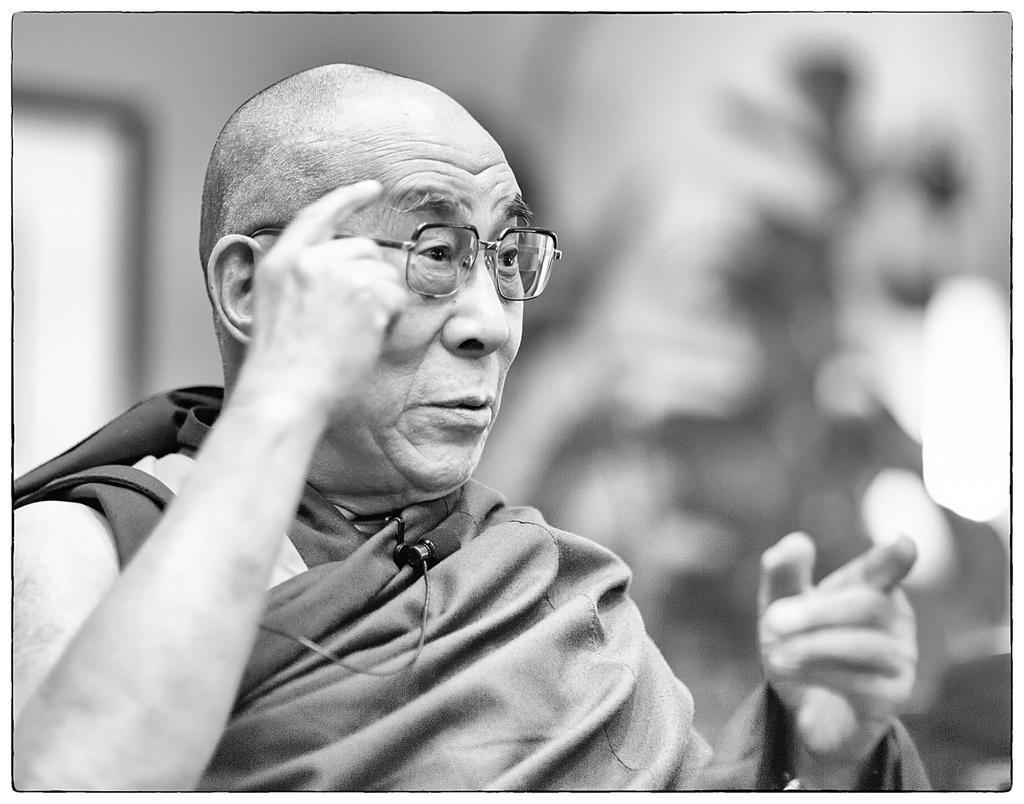Describe this image in one or two sentences. I see that this is a black and white image and I see a man over here who is wearing spectacle and I see a wire over here and it is blurred in the background. 